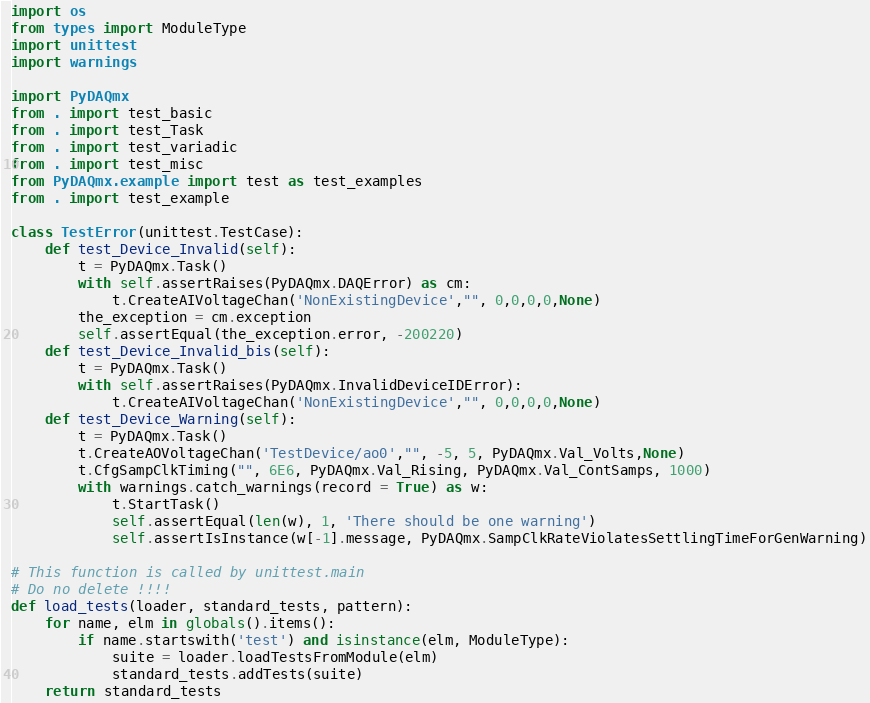<code> <loc_0><loc_0><loc_500><loc_500><_Python_>import os
from types import ModuleType
import unittest
import warnings

import PyDAQmx
from . import test_basic
from . import test_Task
from . import test_variadic
from . import test_misc
from PyDAQmx.example import test as test_examples
from . import test_example

class TestError(unittest.TestCase):
    def test_Device_Invalid(self):
        t = PyDAQmx.Task()
        with self.assertRaises(PyDAQmx.DAQError) as cm:
            t.CreateAIVoltageChan('NonExistingDevice',"", 0,0,0,0,None) 
        the_exception = cm.exception
        self.assertEqual(the_exception.error, -200220)
    def test_Device_Invalid_bis(self):
        t = PyDAQmx.Task()
        with self.assertRaises(PyDAQmx.InvalidDeviceIDError):
            t.CreateAIVoltageChan('NonExistingDevice',"", 0,0,0,0,None) 
    def test_Device_Warning(self):
        t = PyDAQmx.Task()
        t.CreateAOVoltageChan('TestDevice/ao0',"", -5, 5, PyDAQmx.Val_Volts,None)
        t.CfgSampClkTiming("", 6E6, PyDAQmx.Val_Rising, PyDAQmx.Val_ContSamps, 1000)
        with warnings.catch_warnings(record = True) as w:
            t.StartTask()
            self.assertEqual(len(w), 1, 'There should be one warning')  
            self.assertIsInstance(w[-1].message, PyDAQmx.SampClkRateViolatesSettlingTimeForGenWarning)

# This function is called by unittest.main
# Do no delete !!!!
def load_tests(loader, standard_tests, pattern):
    for name, elm in globals().items():
        if name.startswith('test') and isinstance(elm, ModuleType):        
            suite = loader.loadTestsFromModule(elm)
            standard_tests.addTests(suite)
    return standard_tests
</code> 